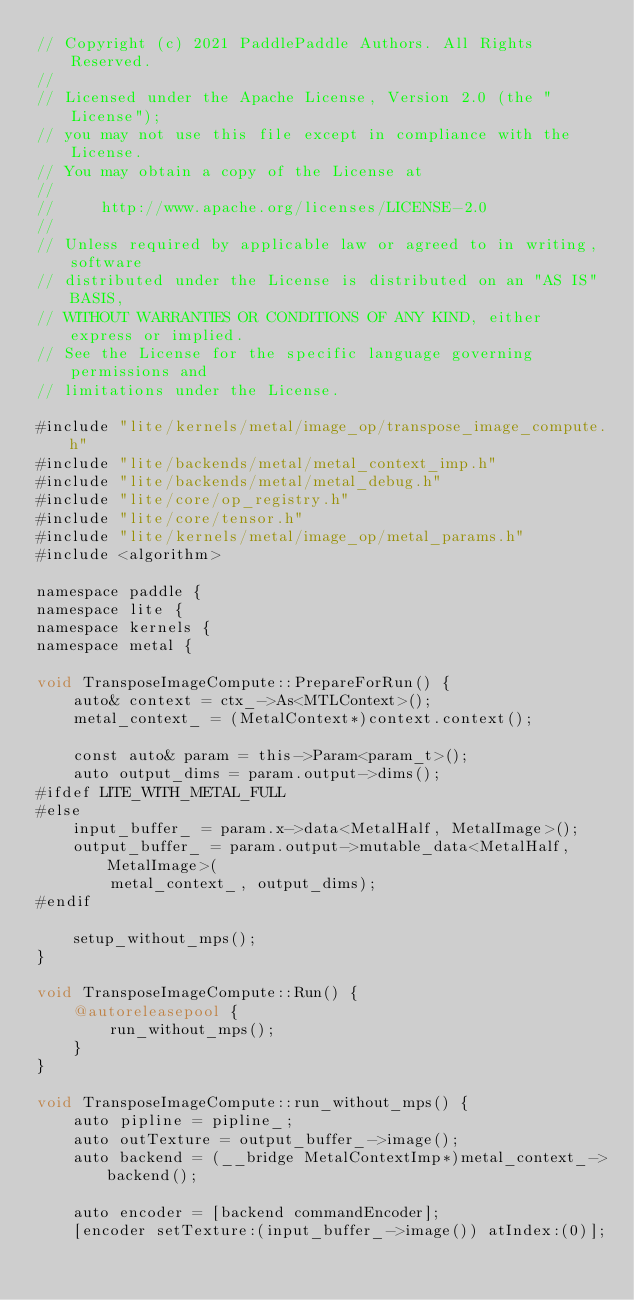Convert code to text. <code><loc_0><loc_0><loc_500><loc_500><_ObjectiveC_>// Copyright (c) 2021 PaddlePaddle Authors. All Rights Reserved.
//
// Licensed under the Apache License, Version 2.0 (the "License");
// you may not use this file except in compliance with the License.
// You may obtain a copy of the License at
//
//     http://www.apache.org/licenses/LICENSE-2.0
//
// Unless required by applicable law or agreed to in writing, software
// distributed under the License is distributed on an "AS IS" BASIS,
// WITHOUT WARRANTIES OR CONDITIONS OF ANY KIND, either express or implied.
// See the License for the specific language governing permissions and
// limitations under the License.

#include "lite/kernels/metal/image_op/transpose_image_compute.h"
#include "lite/backends/metal/metal_context_imp.h"
#include "lite/backends/metal/metal_debug.h"
#include "lite/core/op_registry.h"
#include "lite/core/tensor.h"
#include "lite/kernels/metal/image_op/metal_params.h"
#include <algorithm>

namespace paddle {
namespace lite {
namespace kernels {
namespace metal {

void TransposeImageCompute::PrepareForRun() {
    auto& context = ctx_->As<MTLContext>();
    metal_context_ = (MetalContext*)context.context();

    const auto& param = this->Param<param_t>();
    auto output_dims = param.output->dims();
#ifdef LITE_WITH_METAL_FULL
#else
    input_buffer_ = param.x->data<MetalHalf, MetalImage>();
    output_buffer_ = param.output->mutable_data<MetalHalf, MetalImage>(
        metal_context_, output_dims);
#endif

    setup_without_mps();
}

void TransposeImageCompute::Run() {
    @autoreleasepool {
        run_without_mps();
    }
}

void TransposeImageCompute::run_without_mps() {
    auto pipline = pipline_;
    auto outTexture = output_buffer_->image();
    auto backend = (__bridge MetalContextImp*)metal_context_->backend();

    auto encoder = [backend commandEncoder];
    [encoder setTexture:(input_buffer_->image()) atIndex:(0)];</code> 